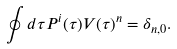<formula> <loc_0><loc_0><loc_500><loc_500>& \oint d \tau P ^ { i } ( \tau ) V ( \tau ) ^ { n } = \delta _ { n , 0 } .</formula> 